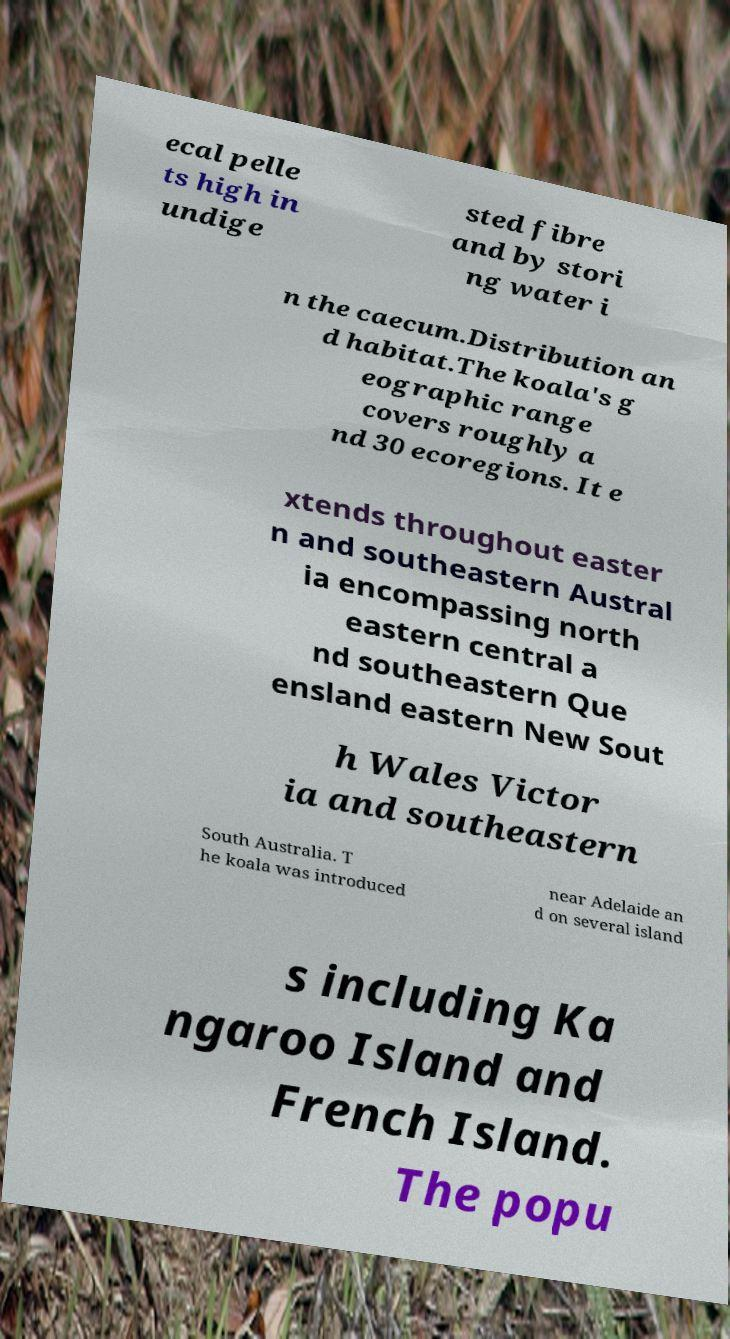Can you read and provide the text displayed in the image?This photo seems to have some interesting text. Can you extract and type it out for me? ecal pelle ts high in undige sted fibre and by stori ng water i n the caecum.Distribution an d habitat.The koala's g eographic range covers roughly a nd 30 ecoregions. It e xtends throughout easter n and southeastern Austral ia encompassing north eastern central a nd southeastern Que ensland eastern New Sout h Wales Victor ia and southeastern South Australia. T he koala was introduced near Adelaide an d on several island s including Ka ngaroo Island and French Island. The popu 